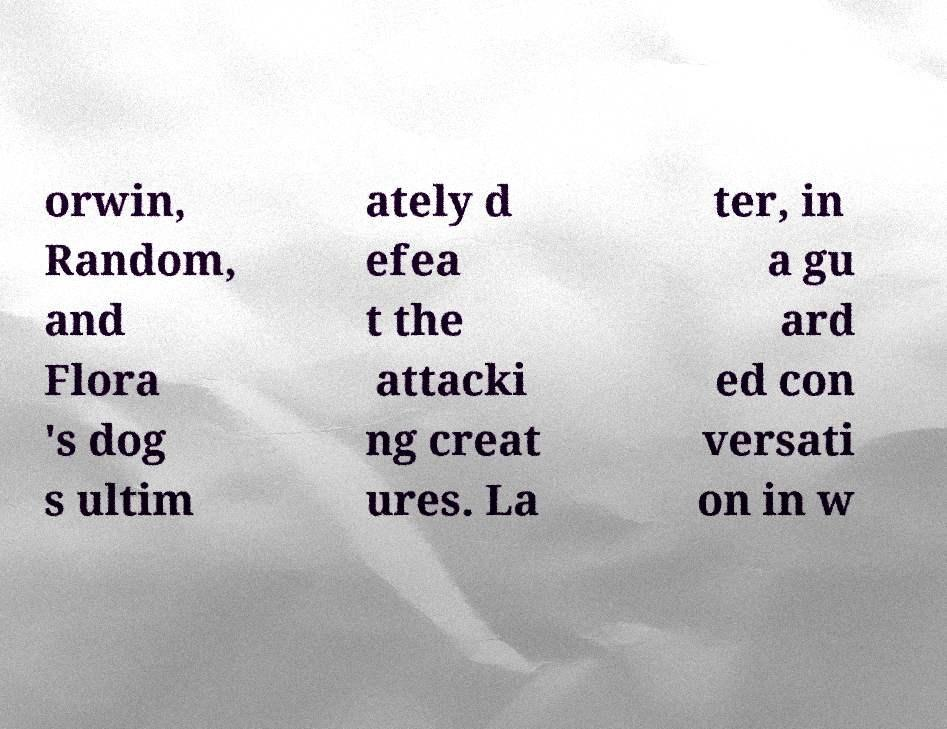For documentation purposes, I need the text within this image transcribed. Could you provide that? orwin, Random, and Flora 's dog s ultim ately d efea t the attacki ng creat ures. La ter, in a gu ard ed con versati on in w 